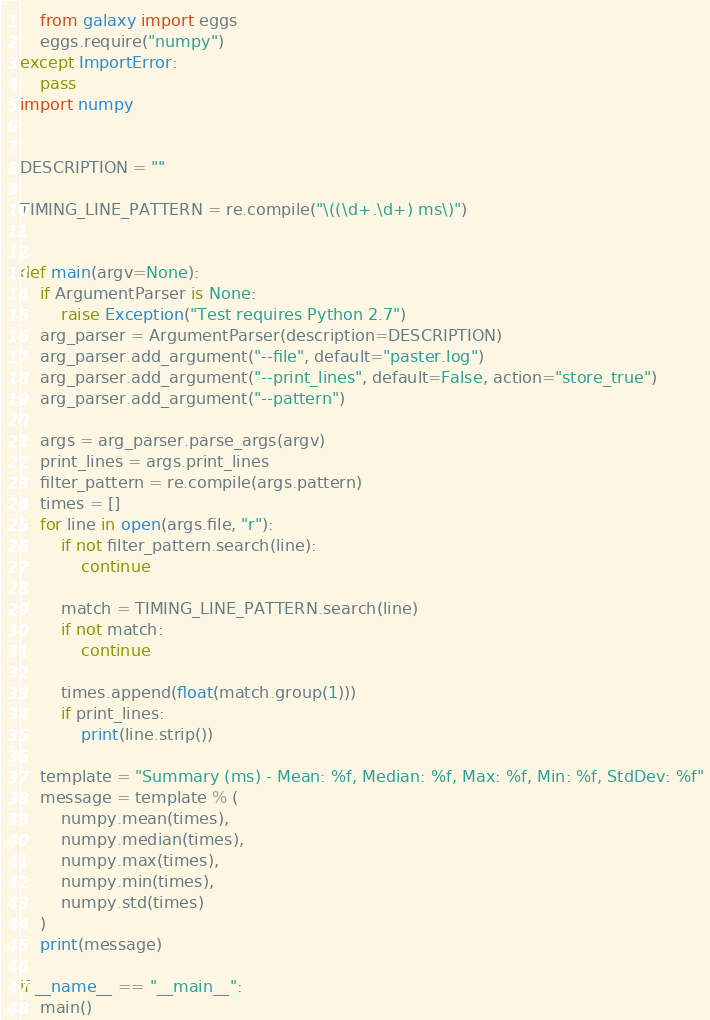Convert code to text. <code><loc_0><loc_0><loc_500><loc_500><_Python_>    from galaxy import eggs
    eggs.require("numpy")
except ImportError:
    pass
import numpy


DESCRIPTION = ""

TIMING_LINE_PATTERN = re.compile("\((\d+.\d+) ms\)")


def main(argv=None):
    if ArgumentParser is None:
        raise Exception("Test requires Python 2.7")
    arg_parser = ArgumentParser(description=DESCRIPTION)
    arg_parser.add_argument("--file", default="paster.log")
    arg_parser.add_argument("--print_lines", default=False, action="store_true")
    arg_parser.add_argument("--pattern")

    args = arg_parser.parse_args(argv)
    print_lines = args.print_lines
    filter_pattern = re.compile(args.pattern)
    times = []
    for line in open(args.file, "r"):
        if not filter_pattern.search(line):
            continue

        match = TIMING_LINE_PATTERN.search(line)
        if not match:
            continue

        times.append(float(match.group(1)))
        if print_lines:
            print(line.strip())

    template = "Summary (ms) - Mean: %f, Median: %f, Max: %f, Min: %f, StdDev: %f"
    message = template % (
        numpy.mean(times),
        numpy.median(times),
        numpy.max(times),
        numpy.min(times),
        numpy.std(times)
    )
    print(message)

if __name__ == "__main__":
    main()
</code> 